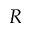Convert formula to latex. <formula><loc_0><loc_0><loc_500><loc_500>R</formula> 